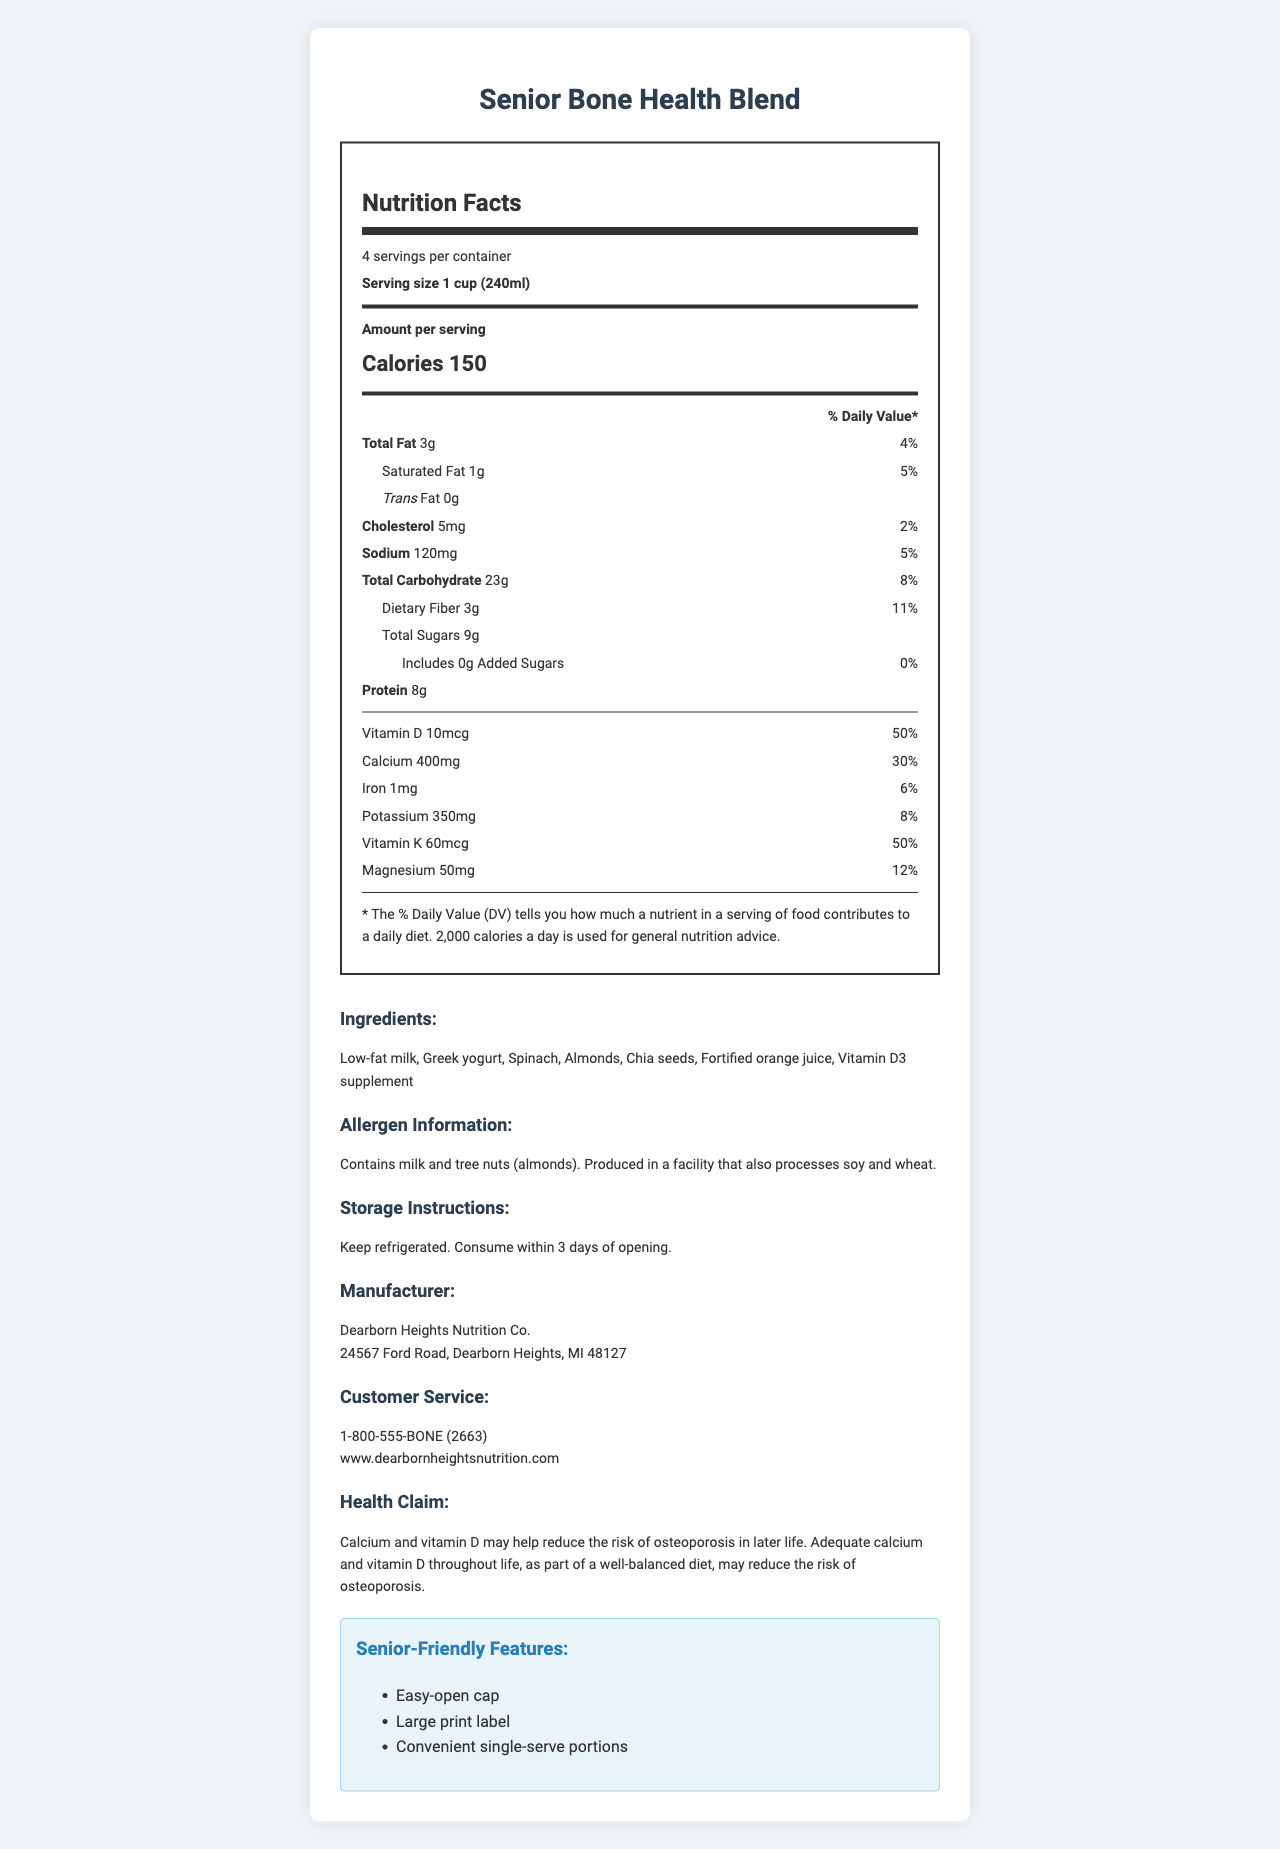what is the serving size for Senior Bone Health Blend? The serving size is mentioned at the beginning of the nutrition label section of the document.
Answer: 1 cup (240ml) how many calories are there per serving? The amount of calories per serving is listed prominently under the "Amount per serving" section.
Answer: 150 what is the amount of calcium per serving in mg? The document specifies the amount of calcium along with the daily value percentage.
Answer: 400mg what percentage of the daily value of vitamin D does one serving provide? This information is listed under the Vitamin D value on the nutrition label.
Answer: 50% how many grams of protein does one serving of Senior Bone Health Blend contain? The protein content is clearly listed on the nutrition label under the nutrients section.
Answer: 8g which of the following ingredients is included in Senior Bone Health Blend? A. Soy Milk B. Greek Yogurt C. Peanut Butter D. Oatmeal The ingredients list mentions Greek yogurt explicitly.
Answer: B. Greek Yogurt how many servings are in one container of Senior Bone Health Blend? A. 2 B. 4 C. 6 D. 8 The document shows that there are 4 servings per container.
Answer: B does the Senior Bone Health Blend contain any added sugars? The label indicates that there are 0g of added sugars in the product.
Answer: No is this product suitable for people who are allergic to tree nuts? Because the allergen information states that the product contains almonds, which are tree nuts.
Answer: No summarize the main idea of this document. The document is a comprehensive description of the nutritional content and additional information about the Senior Bone Health Blend product aimed at providing bone health benefits with calcium and vitamin D.
Answer: The document provides the nutrition facts for the product Senior Bone Health Blend. It highlights the serving size, number of servings per container, calories, and detailed nutrient content, including significant amounts of calcium and vitamin D. It also lists the ingredients, allergen information, storage instructions, manufacturer details, and senior-friendly features. when should the product be consumed after opening? The storage instructions mention that the product should be consumed within 3 days of opening.
Answer: Within 3 days how much total fat is in each serving? The total amount of fat per serving is listed under the nutrient section on the nutrition label.
Answer: 3g who is the manufacturer of the Senior Bone Health Blend? The manufacturer's name and address are provided in the additional info section of the document.
Answer: Dearborn Heights Nutrition Co. why might this product be particularly beneficial for older adults? The health claim specifically mentions the potential benefits of calcium and vitamin D in reducing the risk of osteoporosis, which is particularly relevant for older adults.
Answer: It is high in calcium and vitamin D, which may help reduce the risk of osteoporosis. is there information about the fiber content in this product? The document lists the dietary fiber content as 3g per serving with a daily value of 11%.
Answer: Yes what is the customer service contact number for this product? The customer service contact number is provided in the additional information section.
Answer: 1-800-555-BONE (2663) what is the price of the Senior Bone Health Blend? The document does not provide any pricing information.
Answer: Cannot be determined 